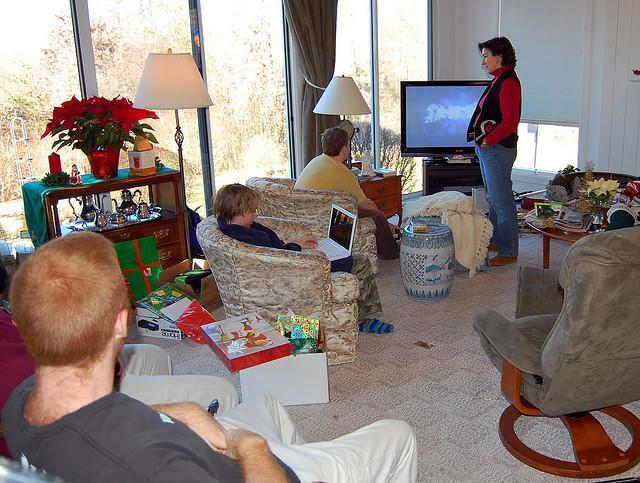How many people in this picture?
Give a very brief answer. 4. How many chairs can be seen?
Give a very brief answer. 3. How many people are there?
Give a very brief answer. 4. 